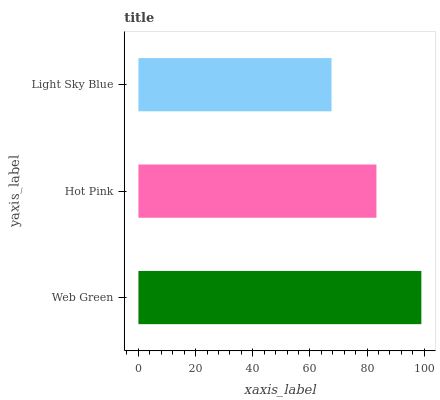Is Light Sky Blue the minimum?
Answer yes or no. Yes. Is Web Green the maximum?
Answer yes or no. Yes. Is Hot Pink the minimum?
Answer yes or no. No. Is Hot Pink the maximum?
Answer yes or no. No. Is Web Green greater than Hot Pink?
Answer yes or no. Yes. Is Hot Pink less than Web Green?
Answer yes or no. Yes. Is Hot Pink greater than Web Green?
Answer yes or no. No. Is Web Green less than Hot Pink?
Answer yes or no. No. Is Hot Pink the high median?
Answer yes or no. Yes. Is Hot Pink the low median?
Answer yes or no. Yes. Is Light Sky Blue the high median?
Answer yes or no. No. Is Light Sky Blue the low median?
Answer yes or no. No. 